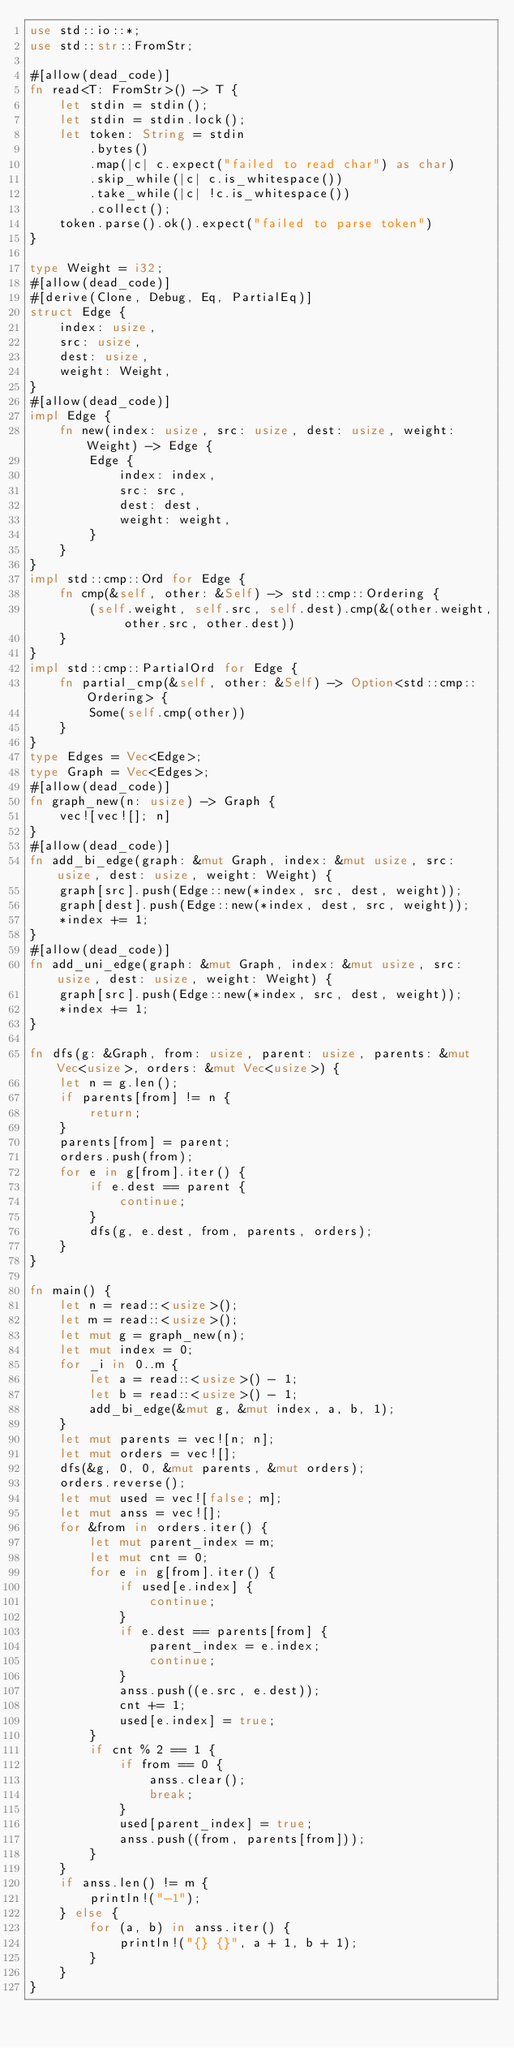<code> <loc_0><loc_0><loc_500><loc_500><_Rust_>use std::io::*;
use std::str::FromStr;

#[allow(dead_code)]
fn read<T: FromStr>() -> T {
    let stdin = stdin();
    let stdin = stdin.lock();
    let token: String = stdin
        .bytes()
        .map(|c| c.expect("failed to read char") as char)
        .skip_while(|c| c.is_whitespace())
        .take_while(|c| !c.is_whitespace())
        .collect();
    token.parse().ok().expect("failed to parse token")
}

type Weight = i32;
#[allow(dead_code)]
#[derive(Clone, Debug, Eq, PartialEq)]
struct Edge {
    index: usize,
    src: usize,
    dest: usize,
    weight: Weight,
}
#[allow(dead_code)]
impl Edge {
    fn new(index: usize, src: usize, dest: usize, weight: Weight) -> Edge {
        Edge {
            index: index,
            src: src,
            dest: dest,
            weight: weight,
        }
    }
}
impl std::cmp::Ord for Edge {
    fn cmp(&self, other: &Self) -> std::cmp::Ordering {
        (self.weight, self.src, self.dest).cmp(&(other.weight, other.src, other.dest))
    }
}
impl std::cmp::PartialOrd for Edge {
    fn partial_cmp(&self, other: &Self) -> Option<std::cmp::Ordering> {
        Some(self.cmp(other))
    }
}
type Edges = Vec<Edge>;
type Graph = Vec<Edges>;
#[allow(dead_code)]
fn graph_new(n: usize) -> Graph {
    vec![vec![]; n]
}
#[allow(dead_code)]
fn add_bi_edge(graph: &mut Graph, index: &mut usize, src: usize, dest: usize, weight: Weight) {
    graph[src].push(Edge::new(*index, src, dest, weight));
    graph[dest].push(Edge::new(*index, dest, src, weight));
    *index += 1;
}
#[allow(dead_code)]
fn add_uni_edge(graph: &mut Graph, index: &mut usize, src: usize, dest: usize, weight: Weight) {
    graph[src].push(Edge::new(*index, src, dest, weight));
    *index += 1;
}

fn dfs(g: &Graph, from: usize, parent: usize, parents: &mut Vec<usize>, orders: &mut Vec<usize>) {
    let n = g.len();
    if parents[from] != n {
        return;
    }
    parents[from] = parent;
    orders.push(from);
    for e in g[from].iter() {
        if e.dest == parent {
            continue;
        }
        dfs(g, e.dest, from, parents, orders);
    }
}

fn main() {
    let n = read::<usize>();
    let m = read::<usize>();
    let mut g = graph_new(n);
    let mut index = 0;
    for _i in 0..m {
        let a = read::<usize>() - 1;
        let b = read::<usize>() - 1;
        add_bi_edge(&mut g, &mut index, a, b, 1);
    }
    let mut parents = vec![n; n];
    let mut orders = vec![];
    dfs(&g, 0, 0, &mut parents, &mut orders);
    orders.reverse();
    let mut used = vec![false; m];
    let mut anss = vec![];
    for &from in orders.iter() {
        let mut parent_index = m;
        let mut cnt = 0;
        for e in g[from].iter() {
            if used[e.index] {
                continue;
            }
            if e.dest == parents[from] {
                parent_index = e.index;
                continue;
            }
            anss.push((e.src, e.dest));
            cnt += 1;
            used[e.index] = true;
        }
        if cnt % 2 == 1 {
            if from == 0 {
                anss.clear();
                break;
            }
            used[parent_index] = true;
            anss.push((from, parents[from]));
        }
    }
    if anss.len() != m {
        println!("-1");
    } else {
        for (a, b) in anss.iter() {
            println!("{} {}", a + 1, b + 1);
        }
    }
}
</code> 